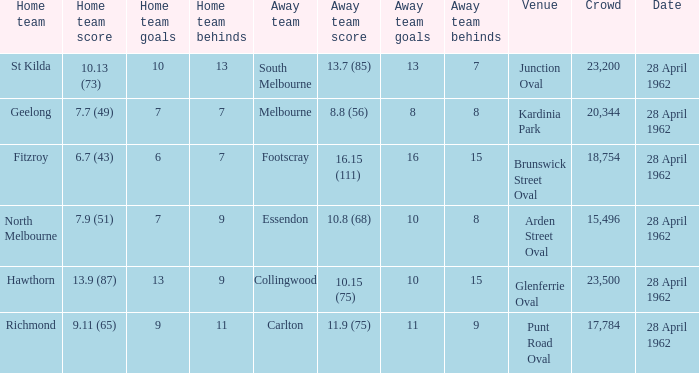What away team played at Brunswick Street Oval? Footscray. Would you be able to parse every entry in this table? {'header': ['Home team', 'Home team score', 'Home team goals', 'Home team behinds', 'Away team', 'Away team score', 'Away team goals', 'Away team behinds', 'Venue', 'Crowd', 'Date'], 'rows': [['St Kilda', '10.13 (73)', '10', '13', 'South Melbourne', '13.7 (85)', '13', '7', 'Junction Oval', '23,200', '28 April 1962'], ['Geelong', '7.7 (49)', '7', '7', 'Melbourne', '8.8 (56)', '8', '8', 'Kardinia Park', '20,344', '28 April 1962'], ['Fitzroy', '6.7 (43)', '6', '7', 'Footscray', '16.15 (111)', '16', '15', 'Brunswick Street Oval', '18,754', '28 April 1962'], ['North Melbourne', '7.9 (51)', '7', '9', 'Essendon', '10.8 (68)', '10', '8', 'Arden Street Oval', '15,496', '28 April 1962'], ['Hawthorn', '13.9 (87)', '13', '9', 'Collingwood', '10.15 (75)', '10', '15', 'Glenferrie Oval', '23,500', '28 April 1962'], ['Richmond', '9.11 (65)', '9', '11', 'Carlton', '11.9 (75)', '11', '9', 'Punt Road Oval', '17,784', '28 April 1962']]} 